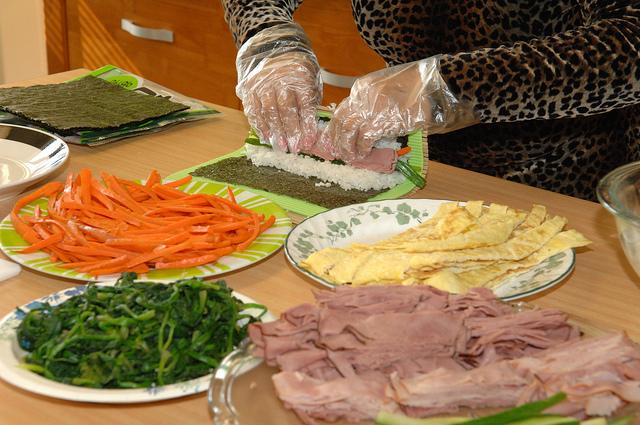What dish is the person assembling these food items to mimic? sushi 